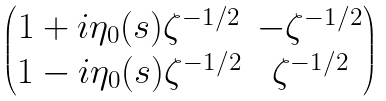Convert formula to latex. <formula><loc_0><loc_0><loc_500><loc_500>\begin{pmatrix} 1 + i \eta _ { 0 } ( s ) \zeta ^ { - 1 / 2 } & - \zeta ^ { - 1 / 2 } \\ 1 - i \eta _ { 0 } ( s ) \zeta ^ { - 1 / 2 } & \zeta ^ { - 1 / 2 } \end{pmatrix}</formula> 